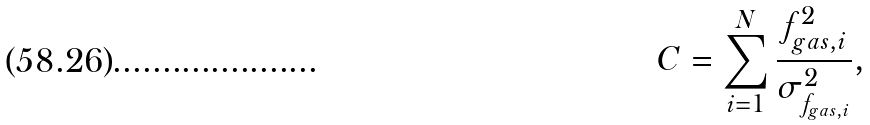Convert formula to latex. <formula><loc_0><loc_0><loc_500><loc_500>C = \sum _ { i = 1 } ^ { N } \frac { f _ { g a s , i } ^ { 2 } } { \sigma ^ { 2 } _ { f _ { g a s , i } } } ,</formula> 